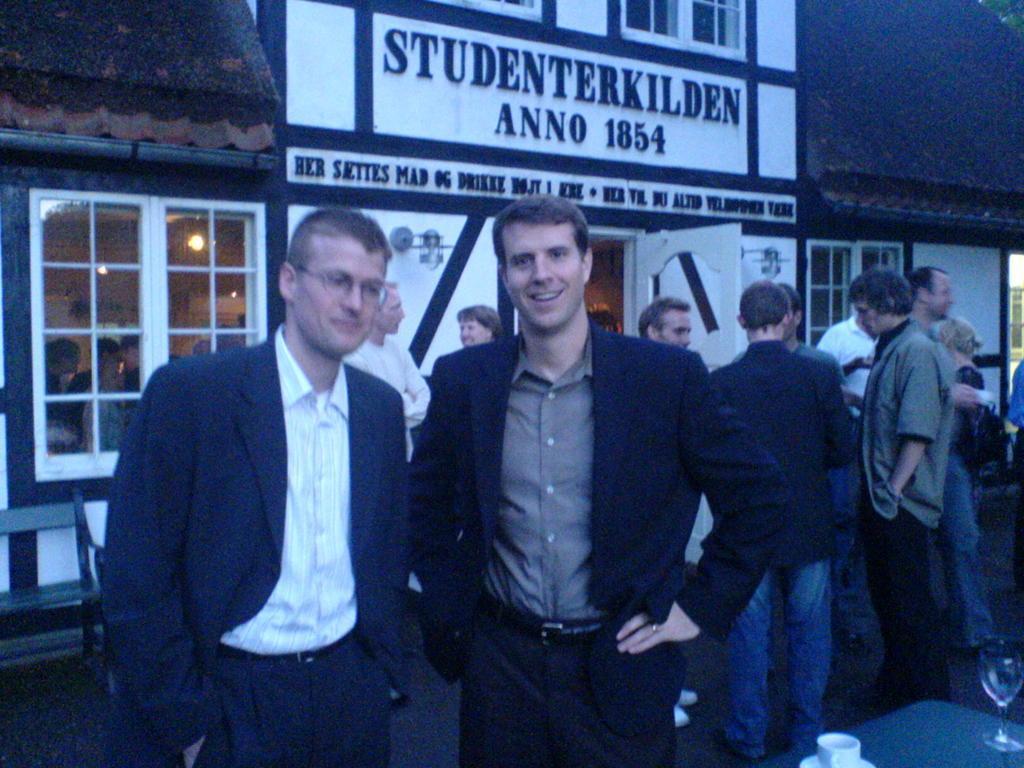Could you give a brief overview of what you see in this image? This image consists of many persons standing on the road. On the right, we can see a table on which there is a wine glass along with a cup and saucer are kept. In the background, there is a house. It looks like a restaurant. At the top, there is a name board. 